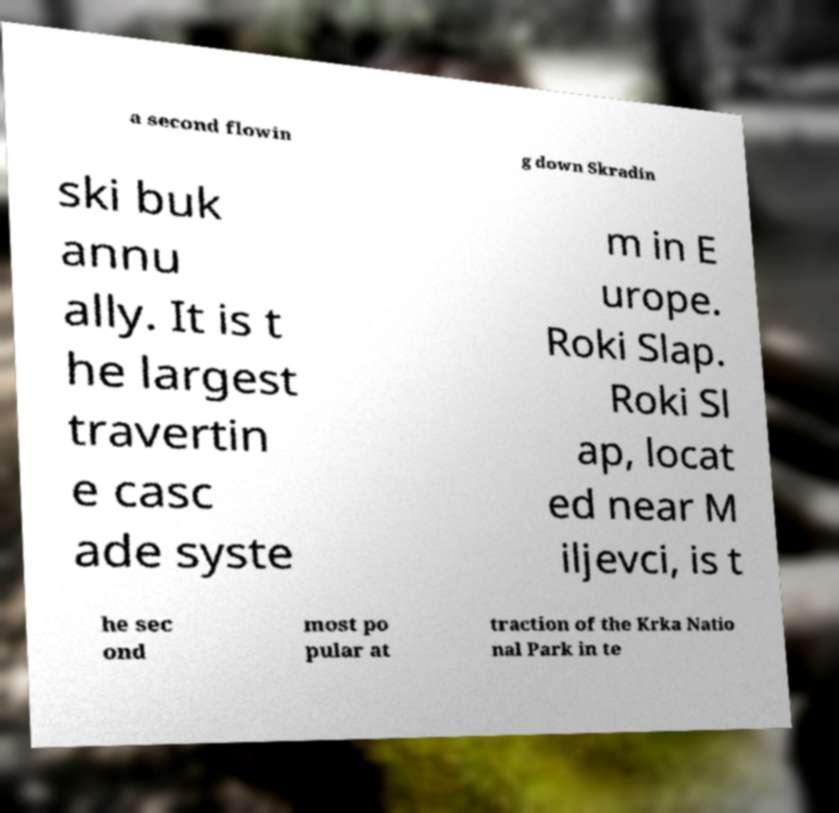Could you assist in decoding the text presented in this image and type it out clearly? a second flowin g down Skradin ski buk annu ally. It is t he largest travertin e casc ade syste m in E urope. Roki Slap. Roki Sl ap, locat ed near M iljevci, is t he sec ond most po pular at traction of the Krka Natio nal Park in te 